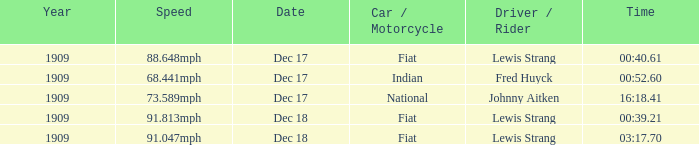Which driver is Indian? Fred Huyck. 